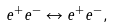Convert formula to latex. <formula><loc_0><loc_0><loc_500><loc_500>e ^ { + } e ^ { - } \leftrightarrow e ^ { + } e ^ { - } ,</formula> 